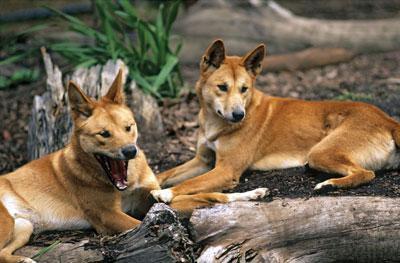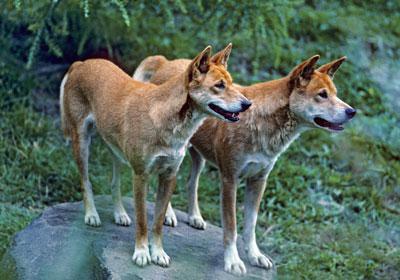The first image is the image on the left, the second image is the image on the right. Analyze the images presented: Is the assertion "There are exactly two animals in the image on the right." valid? Answer yes or no. Yes. 